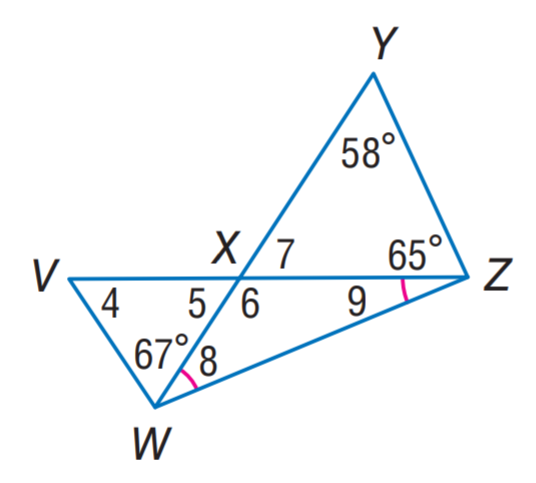Answer the mathemtical geometry problem and directly provide the correct option letter.
Question: Find \angle 6.
Choices: A: 28.5 B: 56 C: 57 D: 123 D 